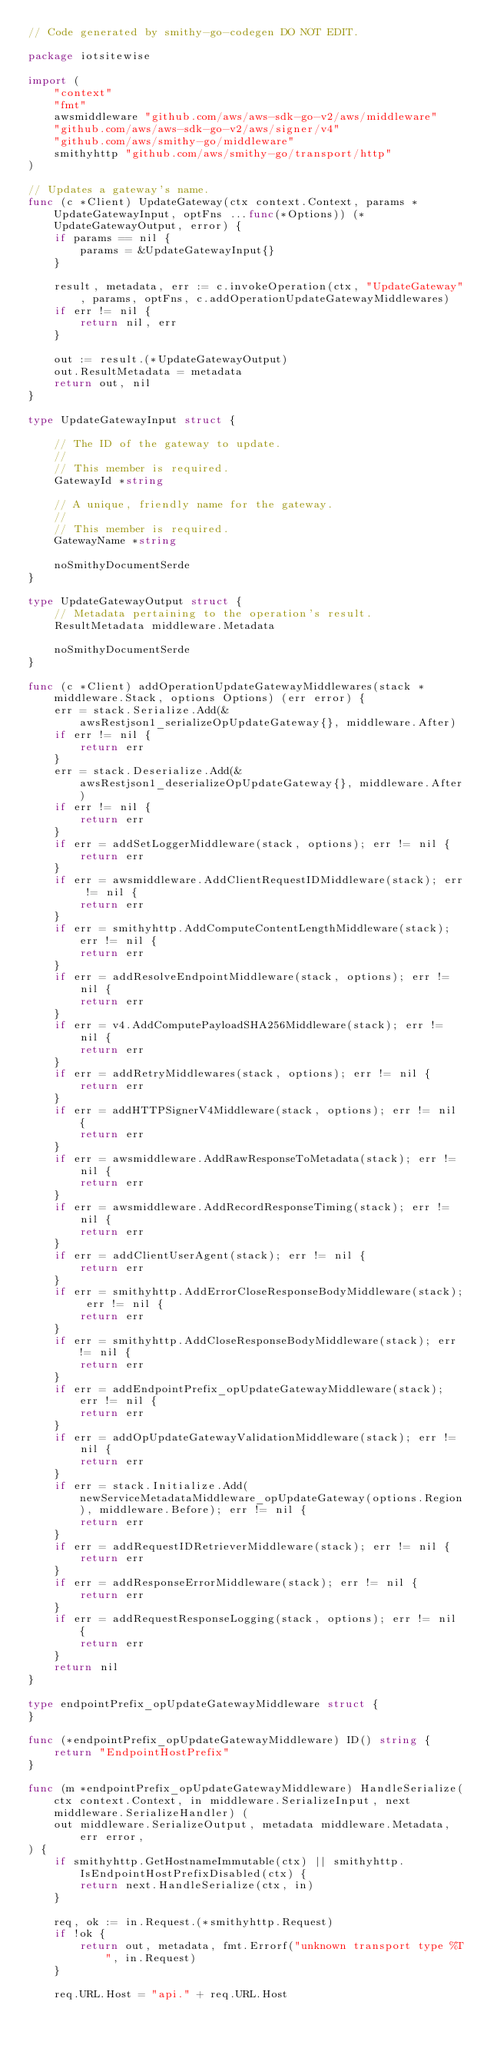Convert code to text. <code><loc_0><loc_0><loc_500><loc_500><_Go_>// Code generated by smithy-go-codegen DO NOT EDIT.

package iotsitewise

import (
	"context"
	"fmt"
	awsmiddleware "github.com/aws/aws-sdk-go-v2/aws/middleware"
	"github.com/aws/aws-sdk-go-v2/aws/signer/v4"
	"github.com/aws/smithy-go/middleware"
	smithyhttp "github.com/aws/smithy-go/transport/http"
)

// Updates a gateway's name.
func (c *Client) UpdateGateway(ctx context.Context, params *UpdateGatewayInput, optFns ...func(*Options)) (*UpdateGatewayOutput, error) {
	if params == nil {
		params = &UpdateGatewayInput{}
	}

	result, metadata, err := c.invokeOperation(ctx, "UpdateGateway", params, optFns, c.addOperationUpdateGatewayMiddlewares)
	if err != nil {
		return nil, err
	}

	out := result.(*UpdateGatewayOutput)
	out.ResultMetadata = metadata
	return out, nil
}

type UpdateGatewayInput struct {

	// The ID of the gateway to update.
	//
	// This member is required.
	GatewayId *string

	// A unique, friendly name for the gateway.
	//
	// This member is required.
	GatewayName *string

	noSmithyDocumentSerde
}

type UpdateGatewayOutput struct {
	// Metadata pertaining to the operation's result.
	ResultMetadata middleware.Metadata

	noSmithyDocumentSerde
}

func (c *Client) addOperationUpdateGatewayMiddlewares(stack *middleware.Stack, options Options) (err error) {
	err = stack.Serialize.Add(&awsRestjson1_serializeOpUpdateGateway{}, middleware.After)
	if err != nil {
		return err
	}
	err = stack.Deserialize.Add(&awsRestjson1_deserializeOpUpdateGateway{}, middleware.After)
	if err != nil {
		return err
	}
	if err = addSetLoggerMiddleware(stack, options); err != nil {
		return err
	}
	if err = awsmiddleware.AddClientRequestIDMiddleware(stack); err != nil {
		return err
	}
	if err = smithyhttp.AddComputeContentLengthMiddleware(stack); err != nil {
		return err
	}
	if err = addResolveEndpointMiddleware(stack, options); err != nil {
		return err
	}
	if err = v4.AddComputePayloadSHA256Middleware(stack); err != nil {
		return err
	}
	if err = addRetryMiddlewares(stack, options); err != nil {
		return err
	}
	if err = addHTTPSignerV4Middleware(stack, options); err != nil {
		return err
	}
	if err = awsmiddleware.AddRawResponseToMetadata(stack); err != nil {
		return err
	}
	if err = awsmiddleware.AddRecordResponseTiming(stack); err != nil {
		return err
	}
	if err = addClientUserAgent(stack); err != nil {
		return err
	}
	if err = smithyhttp.AddErrorCloseResponseBodyMiddleware(stack); err != nil {
		return err
	}
	if err = smithyhttp.AddCloseResponseBodyMiddleware(stack); err != nil {
		return err
	}
	if err = addEndpointPrefix_opUpdateGatewayMiddleware(stack); err != nil {
		return err
	}
	if err = addOpUpdateGatewayValidationMiddleware(stack); err != nil {
		return err
	}
	if err = stack.Initialize.Add(newServiceMetadataMiddleware_opUpdateGateway(options.Region), middleware.Before); err != nil {
		return err
	}
	if err = addRequestIDRetrieverMiddleware(stack); err != nil {
		return err
	}
	if err = addResponseErrorMiddleware(stack); err != nil {
		return err
	}
	if err = addRequestResponseLogging(stack, options); err != nil {
		return err
	}
	return nil
}

type endpointPrefix_opUpdateGatewayMiddleware struct {
}

func (*endpointPrefix_opUpdateGatewayMiddleware) ID() string {
	return "EndpointHostPrefix"
}

func (m *endpointPrefix_opUpdateGatewayMiddleware) HandleSerialize(ctx context.Context, in middleware.SerializeInput, next middleware.SerializeHandler) (
	out middleware.SerializeOutput, metadata middleware.Metadata, err error,
) {
	if smithyhttp.GetHostnameImmutable(ctx) || smithyhttp.IsEndpointHostPrefixDisabled(ctx) {
		return next.HandleSerialize(ctx, in)
	}

	req, ok := in.Request.(*smithyhttp.Request)
	if !ok {
		return out, metadata, fmt.Errorf("unknown transport type %T", in.Request)
	}

	req.URL.Host = "api." + req.URL.Host
</code> 